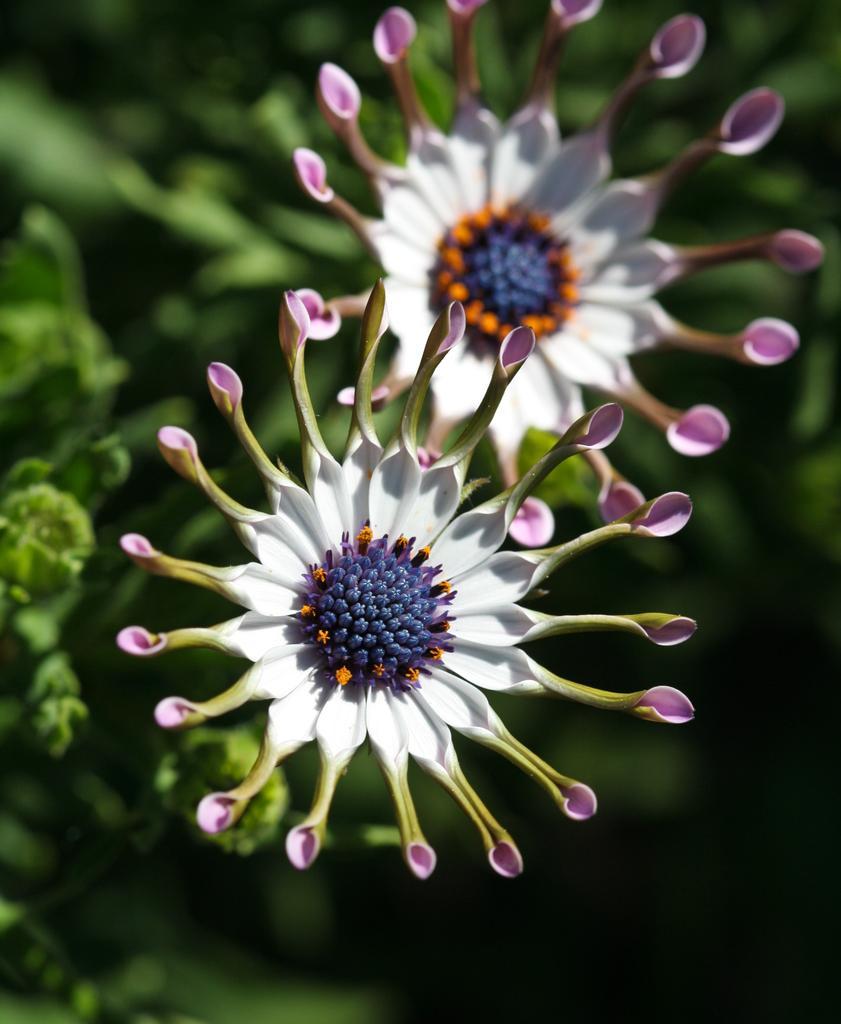Could you give a brief overview of what you see in this image? In this image in the center there are flowers and the background is blurry. 